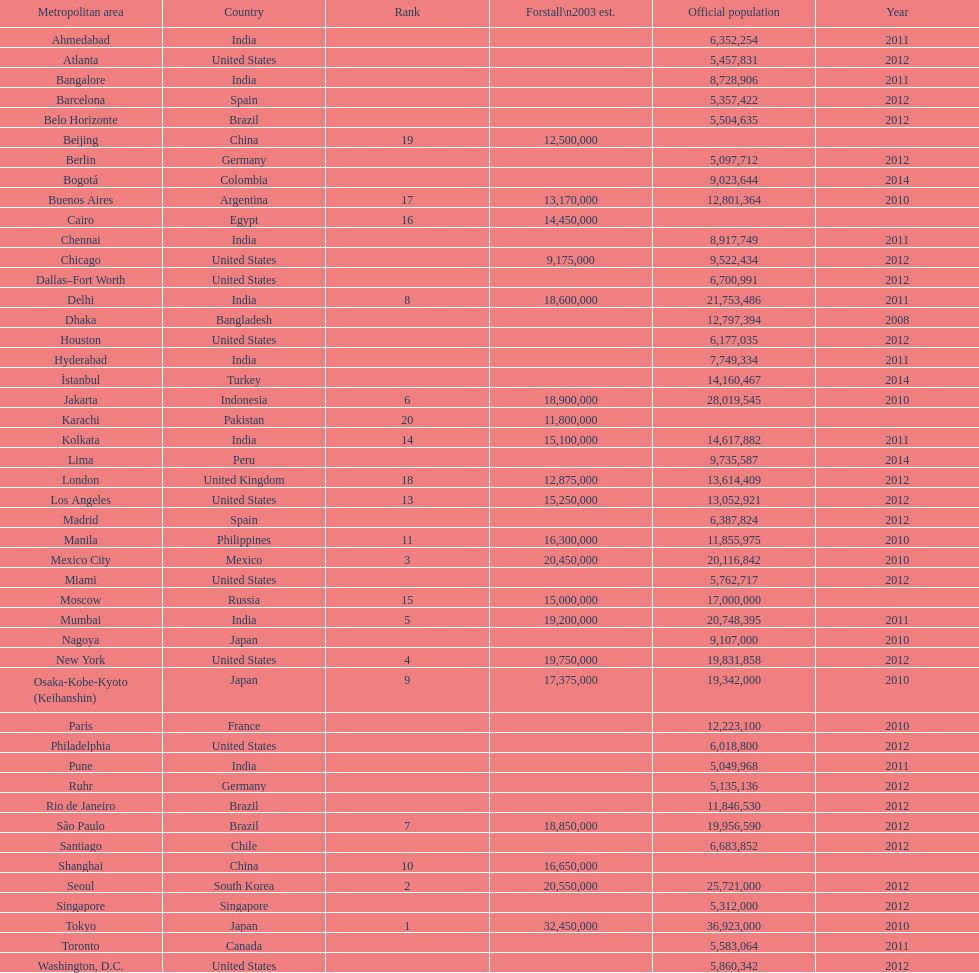Identify a city in the same nation as bangalore. Ahmedabad. 